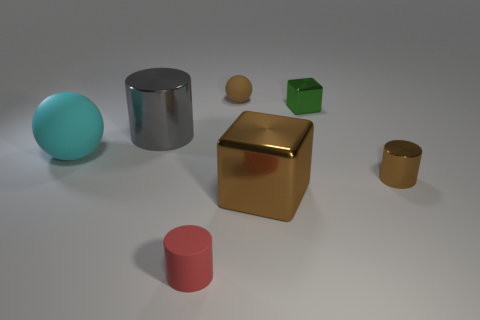Do the big block and the small metal cylinder have the same color?
Make the answer very short. Yes. What material is the small cylinder that is to the left of the big shiny thing in front of the big ball made of?
Offer a terse response. Rubber. There is a metallic block that is behind the large object that is to the right of the tiny thing that is left of the brown rubber sphere; what size is it?
Your answer should be compact. Small. Is the size of the gray cylinder the same as the red matte cylinder?
Ensure brevity in your answer.  No. Do the large shiny object that is behind the big matte ball and the small brown object that is in front of the big cyan rubber object have the same shape?
Give a very brief answer. Yes. Are there any objects that are left of the small cylinder that is on the left side of the tiny brown sphere?
Give a very brief answer. Yes. Are any red rubber cylinders visible?
Your answer should be compact. Yes. How many rubber objects have the same size as the brown cylinder?
Your response must be concise. 2. What number of blocks are both behind the small metallic cylinder and in front of the tiny shiny cylinder?
Make the answer very short. 0. There is a brown object in front of the brown metal cylinder; is its size the same as the small brown sphere?
Your answer should be very brief. No. 